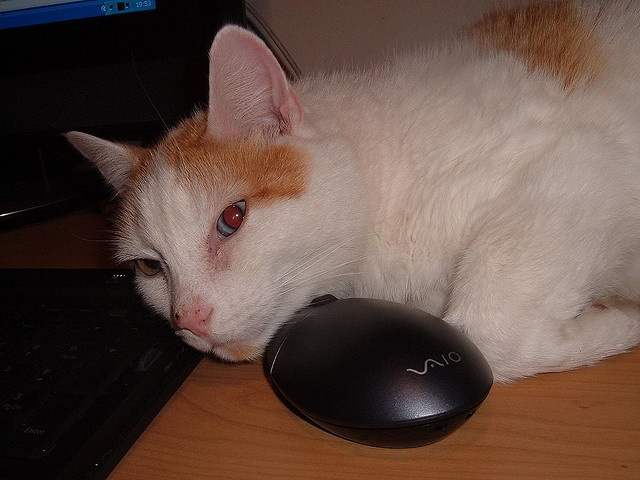Describe the objects in this image and their specific colors. I can see cat in black, darkgray, and gray tones, tv in black, navy, maroon, and gray tones, keyboard in black and gray tones, and mouse in black, gray, and maroon tones in this image. 